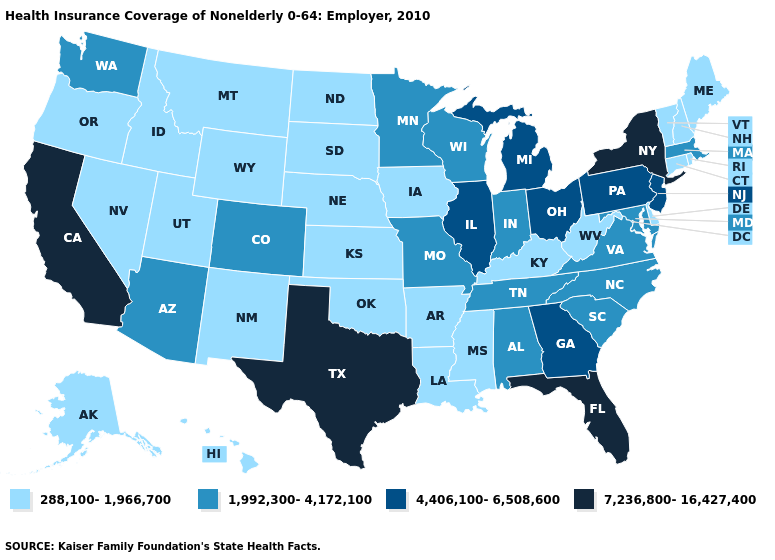Name the states that have a value in the range 7,236,800-16,427,400?
Concise answer only. California, Florida, New York, Texas. What is the value of West Virginia?
Concise answer only. 288,100-1,966,700. What is the highest value in the MidWest ?
Short answer required. 4,406,100-6,508,600. What is the lowest value in the USA?
Write a very short answer. 288,100-1,966,700. Which states have the lowest value in the Northeast?
Concise answer only. Connecticut, Maine, New Hampshire, Rhode Island, Vermont. How many symbols are there in the legend?
Write a very short answer. 4. Which states have the highest value in the USA?
Short answer required. California, Florida, New York, Texas. Name the states that have a value in the range 7,236,800-16,427,400?
Write a very short answer. California, Florida, New York, Texas. What is the value of Georgia?
Answer briefly. 4,406,100-6,508,600. Which states have the lowest value in the South?
Quick response, please. Arkansas, Delaware, Kentucky, Louisiana, Mississippi, Oklahoma, West Virginia. Name the states that have a value in the range 4,406,100-6,508,600?
Short answer required. Georgia, Illinois, Michigan, New Jersey, Ohio, Pennsylvania. What is the value of Wisconsin?
Keep it brief. 1,992,300-4,172,100. What is the highest value in the Northeast ?
Concise answer only. 7,236,800-16,427,400. Name the states that have a value in the range 4,406,100-6,508,600?
Write a very short answer. Georgia, Illinois, Michigan, New Jersey, Ohio, Pennsylvania. Which states have the lowest value in the USA?
Be succinct. Alaska, Arkansas, Connecticut, Delaware, Hawaii, Idaho, Iowa, Kansas, Kentucky, Louisiana, Maine, Mississippi, Montana, Nebraska, Nevada, New Hampshire, New Mexico, North Dakota, Oklahoma, Oregon, Rhode Island, South Dakota, Utah, Vermont, West Virginia, Wyoming. 